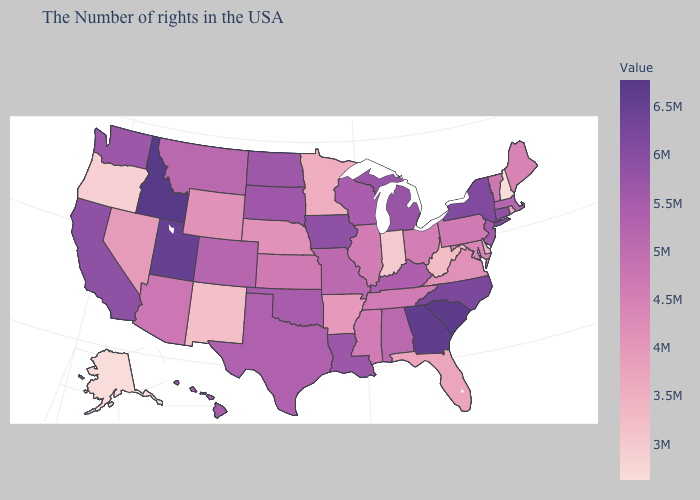Which states have the lowest value in the West?
Short answer required. Alaska. Which states hav the highest value in the West?
Keep it brief. Idaho. Which states have the lowest value in the USA?
Be succinct. New Hampshire, Alaska. Is the legend a continuous bar?
Short answer required. Yes. Does Washington have the highest value in the West?
Keep it brief. No. Which states hav the highest value in the Northeast?
Be succinct. New York. 